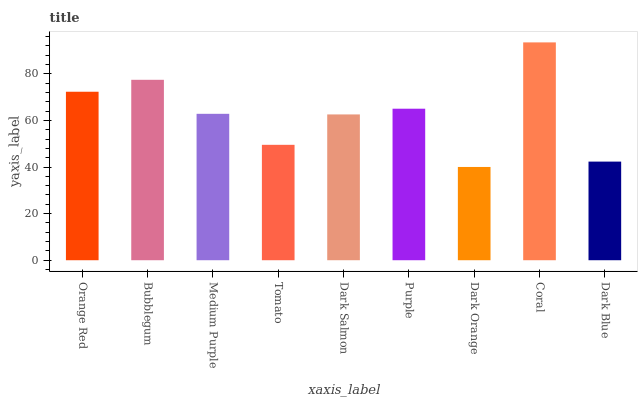Is Dark Orange the minimum?
Answer yes or no. Yes. Is Coral the maximum?
Answer yes or no. Yes. Is Bubblegum the minimum?
Answer yes or no. No. Is Bubblegum the maximum?
Answer yes or no. No. Is Bubblegum greater than Orange Red?
Answer yes or no. Yes. Is Orange Red less than Bubblegum?
Answer yes or no. Yes. Is Orange Red greater than Bubblegum?
Answer yes or no. No. Is Bubblegum less than Orange Red?
Answer yes or no. No. Is Medium Purple the high median?
Answer yes or no. Yes. Is Medium Purple the low median?
Answer yes or no. Yes. Is Orange Red the high median?
Answer yes or no. No. Is Orange Red the low median?
Answer yes or no. No. 